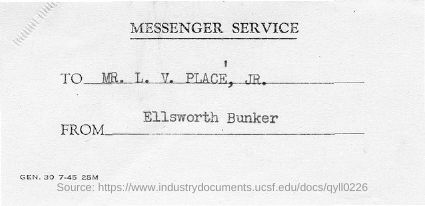Outline some significant characteristics in this image. The message is from Ellsworth Bunker. 